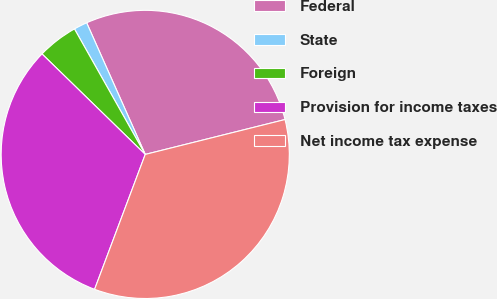Convert chart. <chart><loc_0><loc_0><loc_500><loc_500><pie_chart><fcel>Federal<fcel>State<fcel>Foreign<fcel>Provision for income taxes<fcel>Net income tax expense<nl><fcel>27.77%<fcel>1.51%<fcel>4.54%<fcel>31.57%<fcel>34.61%<nl></chart> 